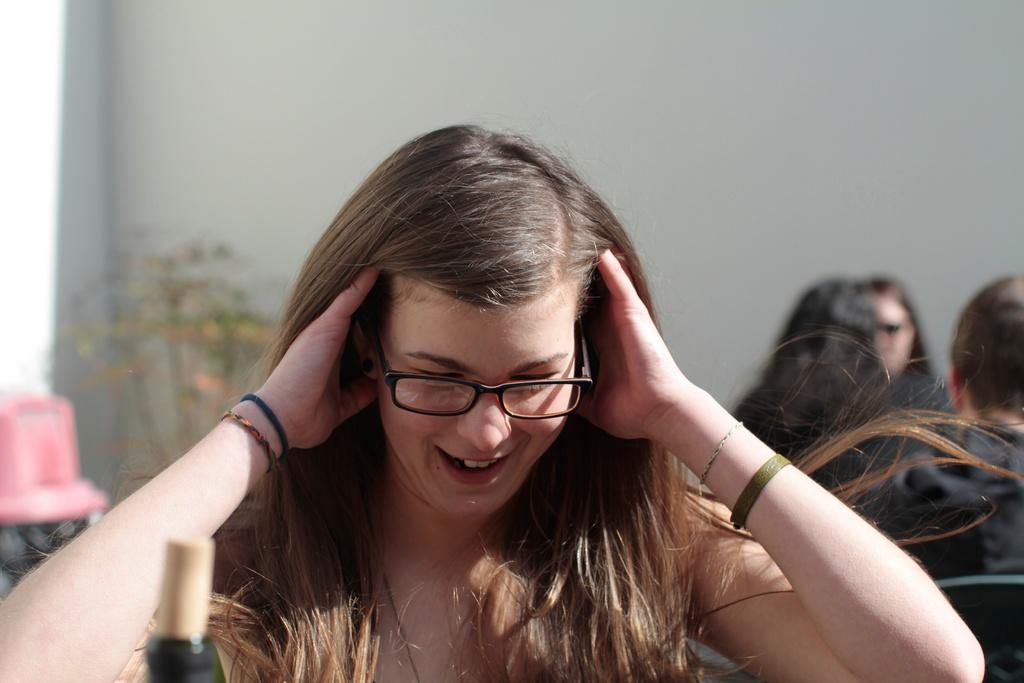What are the people in the image doing? The people in the image are sitting. What can be seen on the left side of the image? There is a pink color object and a plant on the left side of the image. What is visible in the background of the image? There is a wall in the background of the image. What type of animals can be seen at the zoo in the image? There is no zoo present in the image, so it is not possible to determine what, if any, animals might be seen. 